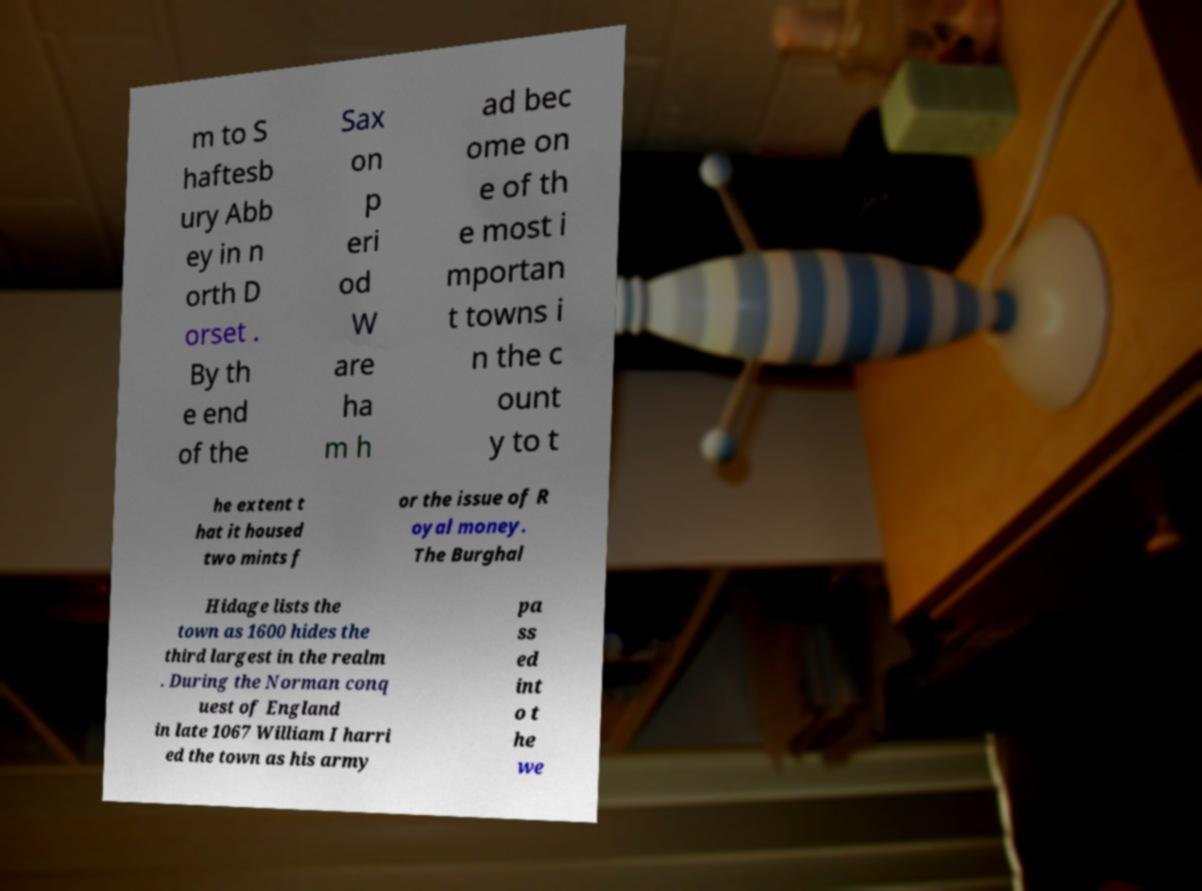Can you read and provide the text displayed in the image?This photo seems to have some interesting text. Can you extract and type it out for me? m to S haftesb ury Abb ey in n orth D orset . By th e end of the Sax on p eri od W are ha m h ad bec ome on e of th e most i mportan t towns i n the c ount y to t he extent t hat it housed two mints f or the issue of R oyal money. The Burghal Hidage lists the town as 1600 hides the third largest in the realm . During the Norman conq uest of England in late 1067 William I harri ed the town as his army pa ss ed int o t he we 